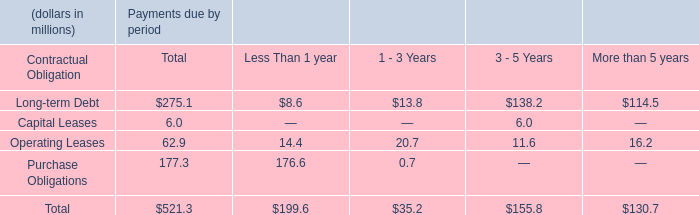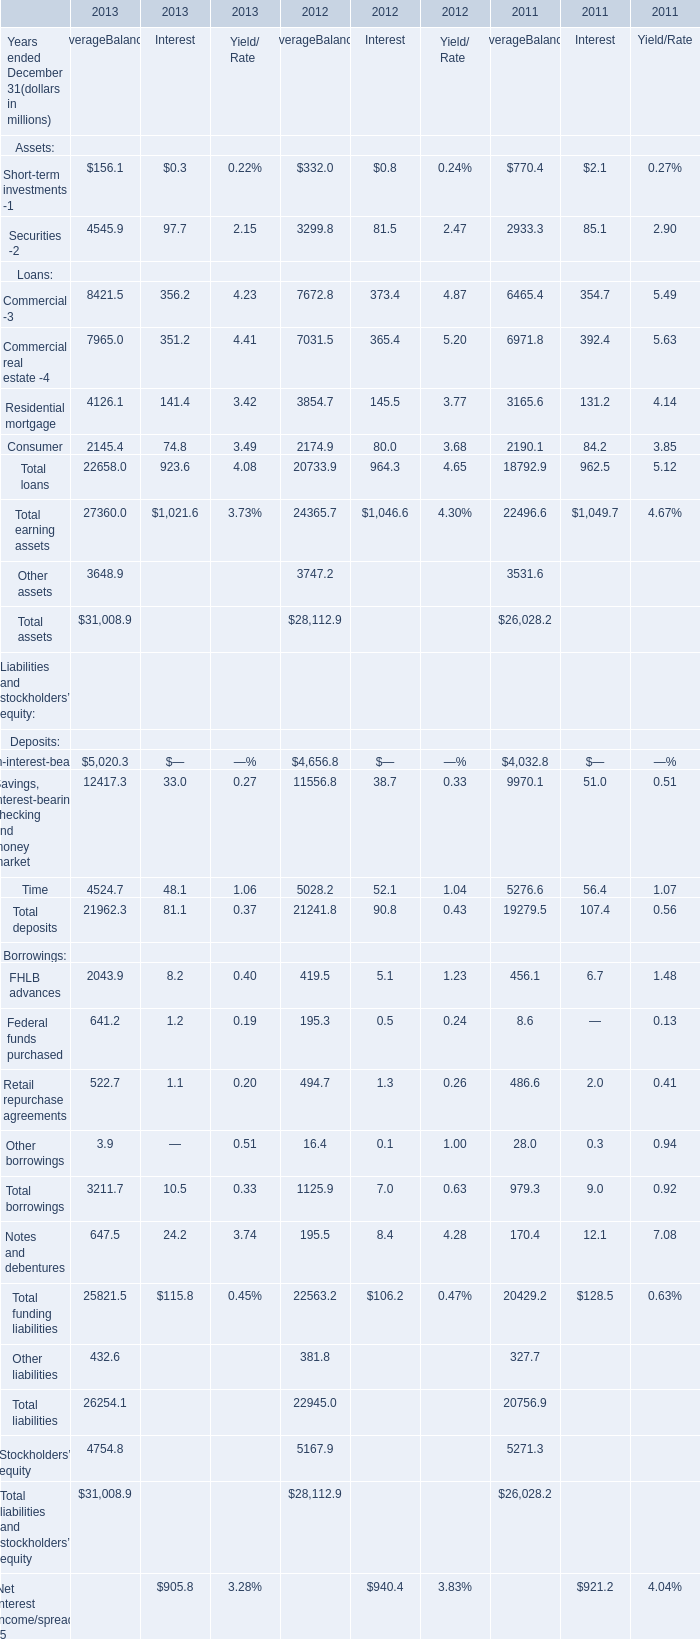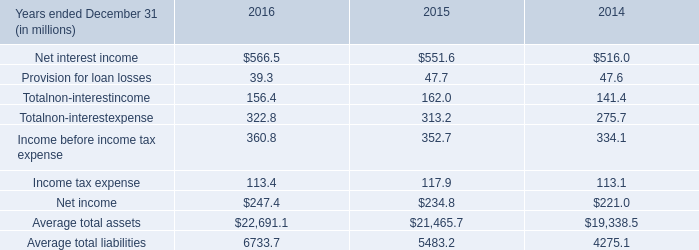In which year ended December 31 is Average Balance for Other assets greater than 3700 million? 
Answer: 2012. 